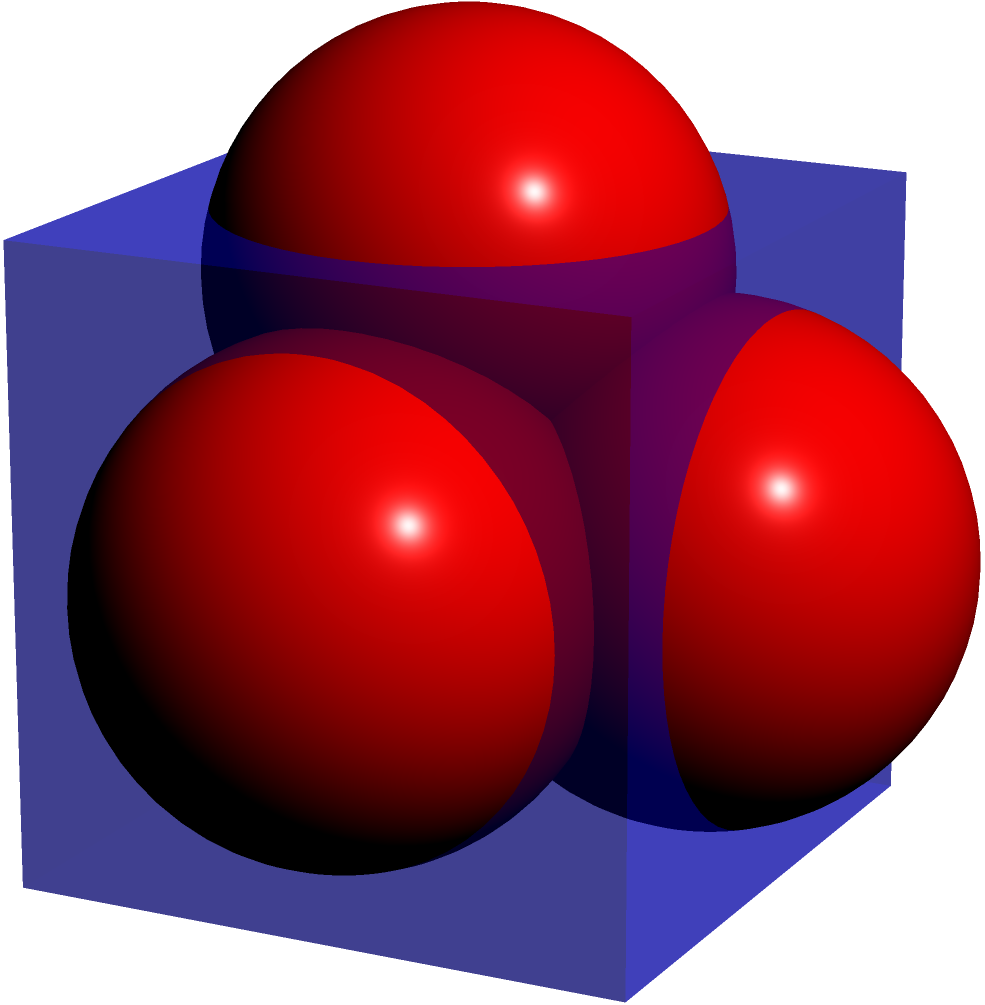For a literary festival, you're planning to decorate a cubical event space with spherical ornaments. The space measures 10 feet on each side, and each spherical decoration has a diameter of 2 feet. Assuming optimal packing, how many spherical decorations can fit inside the event space? To solve this problem, we'll follow these steps:

1) First, we need to determine how many spheres can fit along each edge of the cube:
   - Cube edge length = 10 feet
   - Sphere diameter = 2 feet
   - Number of spheres per edge = $\frac{10}{2} = 5$

2) Now, we can calculate the total number of spheres that can fit in the cube:
   - The arrangement will be 5 x 5 x 5
   - Total spheres = $5 \times 5 \times 5 = 125$

3) However, this assumes perfect cubic packing, which is not the most efficient for spheres.

4) The most efficient packing of equal spheres, known as close-packing of equal spheres, has a packing density of approximately 74.048%.

5) To calculate the actual number of spheres:
   - Volume of cube = $10 \times 10 \times 10 = 1000$ cubic feet
   - Volume of one sphere = $\frac{4}{3}\pi r^3 = \frac{4}{3}\pi 1^3 \approx 4.189$ cubic feet
   - Number of spheres = $\frac{1000 \times 0.74048}{4.189} \approx 176.77$

6) Since we can't have a fraction of a sphere, we round down to the nearest whole number.
Answer: 176 spherical decorations 